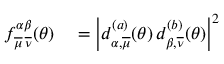Convert formula to latex. <formula><loc_0><loc_0><loc_500><loc_500>\begin{array} { r l } { f _ { \overline { \mu } \, \overline { \nu } } ^ { \alpha \beta } ( \theta ) } & = \left | d _ { \alpha , \overline { \mu } } ^ { ( a ) } ( \theta ) \, d _ { \beta , \overline { \nu } } ^ { ( b ) } ( \theta ) \right | ^ { 2 } } \end{array}</formula> 